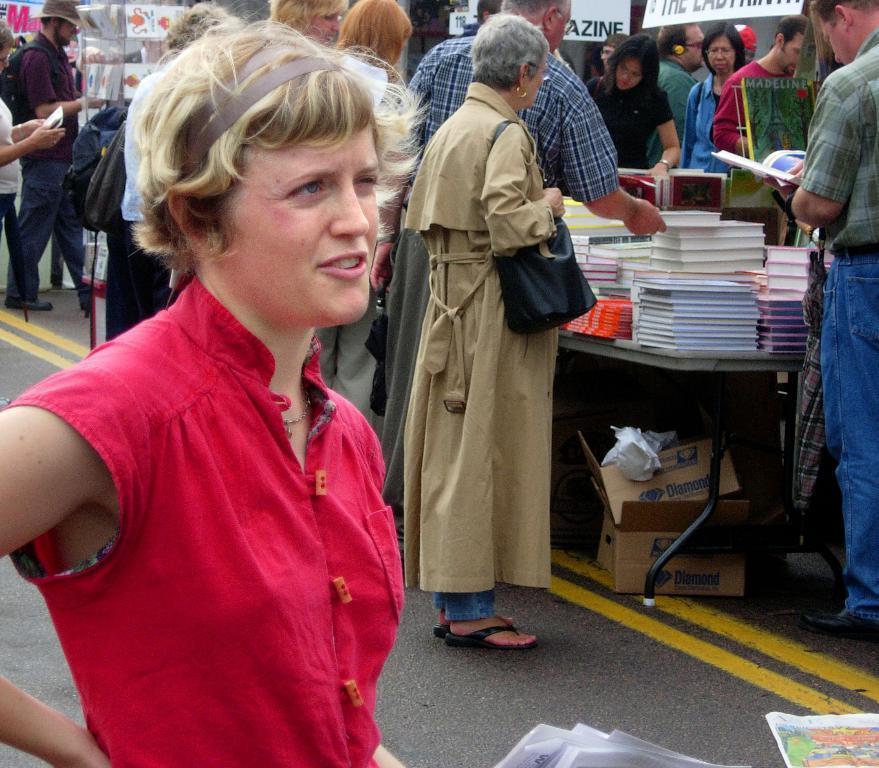Can you describe this image briefly? In this image there is one person standing on the bottom left side of this image is wearing red color dress and there one table on the right side of this image and there are some books kept on it. there are some object kept below to this table. There are some persons standing in the background. There are some papers kept on the bottom right corner of this image. and as we can see there is a road on the bottom of this image. 